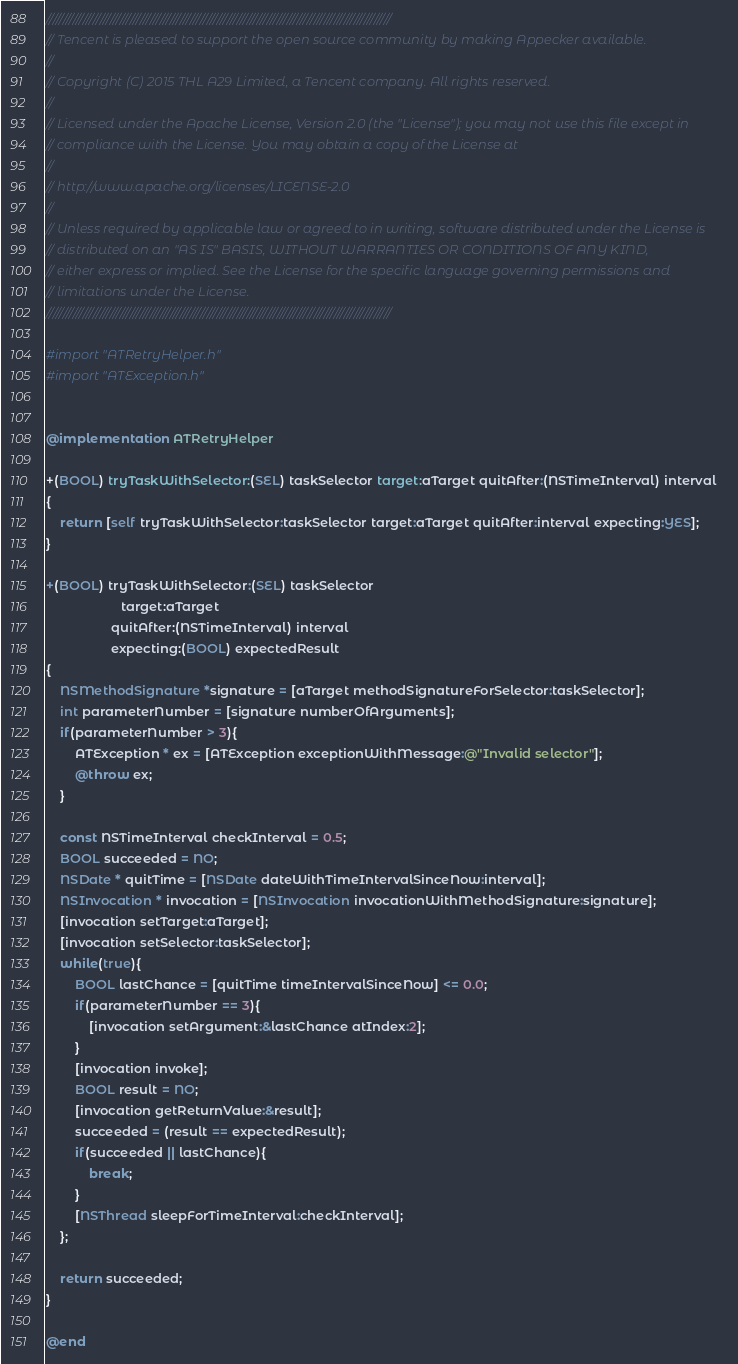Convert code to text. <code><loc_0><loc_0><loc_500><loc_500><_ObjectiveC_>///////////////////////////////////////////////////////////////////////////////////////////////////////
// Tencent is pleased to support the open source community by making Appecker available.
// 
// Copyright (C) 2015 THL A29 Limited, a Tencent company. All rights reserved.
// 
// Licensed under the Apache License, Version 2.0 (the "License"); you may not use this file except in
// compliance with the License. You may obtain a copy of the License at
// 
// http://www.apache.org/licenses/LICENSE-2.0
// 
// Unless required by applicable law or agreed to in writing, software distributed under the License is
// distributed on an "AS IS" BASIS, WITHOUT WARRANTIES OR CONDITIONS OF ANY KIND,
// either express or implied. See the License for the specific language governing permissions and
// limitations under the License.
///////////////////////////////////////////////////////////////////////////////////////////////////////

#import "ATRetryHelper.h"
#import "ATException.h"


@implementation ATRetryHelper

+(BOOL) tryTaskWithSelector:(SEL) taskSelector target:aTarget quitAfter:(NSTimeInterval) interval
{
    return [self tryTaskWithSelector:taskSelector target:aTarget quitAfter:interval expecting:YES];
}

+(BOOL) tryTaskWithSelector:(SEL) taskSelector
                     target:aTarget
                  quitAfter:(NSTimeInterval) interval
                  expecting:(BOOL) expectedResult
{
    NSMethodSignature *signature = [aTarget methodSignatureForSelector:taskSelector];
    int parameterNumber = [signature numberOfArguments];
    if(parameterNumber > 3){
        ATException * ex = [ATException exceptionWithMessage:@"Invalid selector"];
        @throw ex;
    }

    const NSTimeInterval checkInterval = 0.5;
    BOOL succeeded = NO;
    NSDate * quitTime = [NSDate dateWithTimeIntervalSinceNow:interval];
    NSInvocation * invocation = [NSInvocation invocationWithMethodSignature:signature];
    [invocation setTarget:aTarget];
    [invocation setSelector:taskSelector];
    while(true){
        BOOL lastChance = [quitTime timeIntervalSinceNow] <= 0.0;
        if(parameterNumber == 3){
            [invocation setArgument:&lastChance atIndex:2];
        }
        [invocation invoke];
        BOOL result = NO;
        [invocation getReturnValue:&result];
        succeeded = (result == expectedResult);
        if(succeeded || lastChance){
            break;
        }
        [NSThread sleepForTimeInterval:checkInterval];
    };

    return succeeded;
}

@end
</code> 